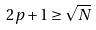Convert formula to latex. <formula><loc_0><loc_0><loc_500><loc_500>2 p + 1 \geq \sqrt { N }</formula> 